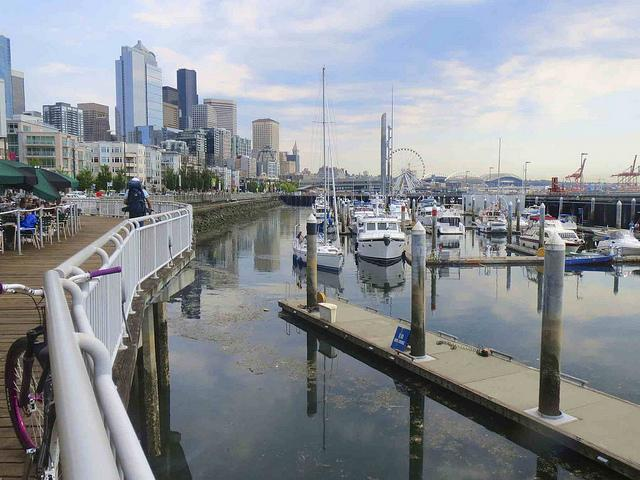What area is shown here? Please explain your reasoning. harbor. There are wooden floors with guard rails and water below with a wooden walkway. there are boats all around. 